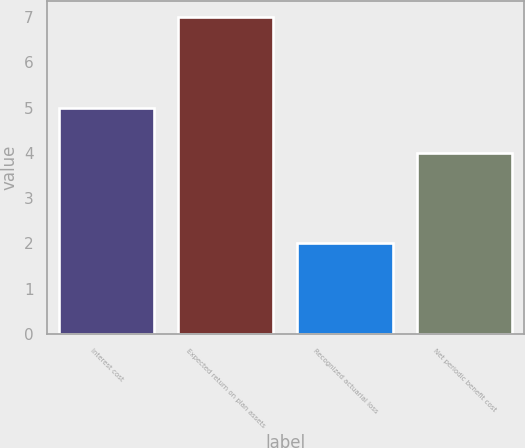Convert chart to OTSL. <chart><loc_0><loc_0><loc_500><loc_500><bar_chart><fcel>Interest cost<fcel>Expected return on plan assets<fcel>Recognized actuarial loss<fcel>Net periodic benefit cost<nl><fcel>5<fcel>7<fcel>2<fcel>4<nl></chart> 